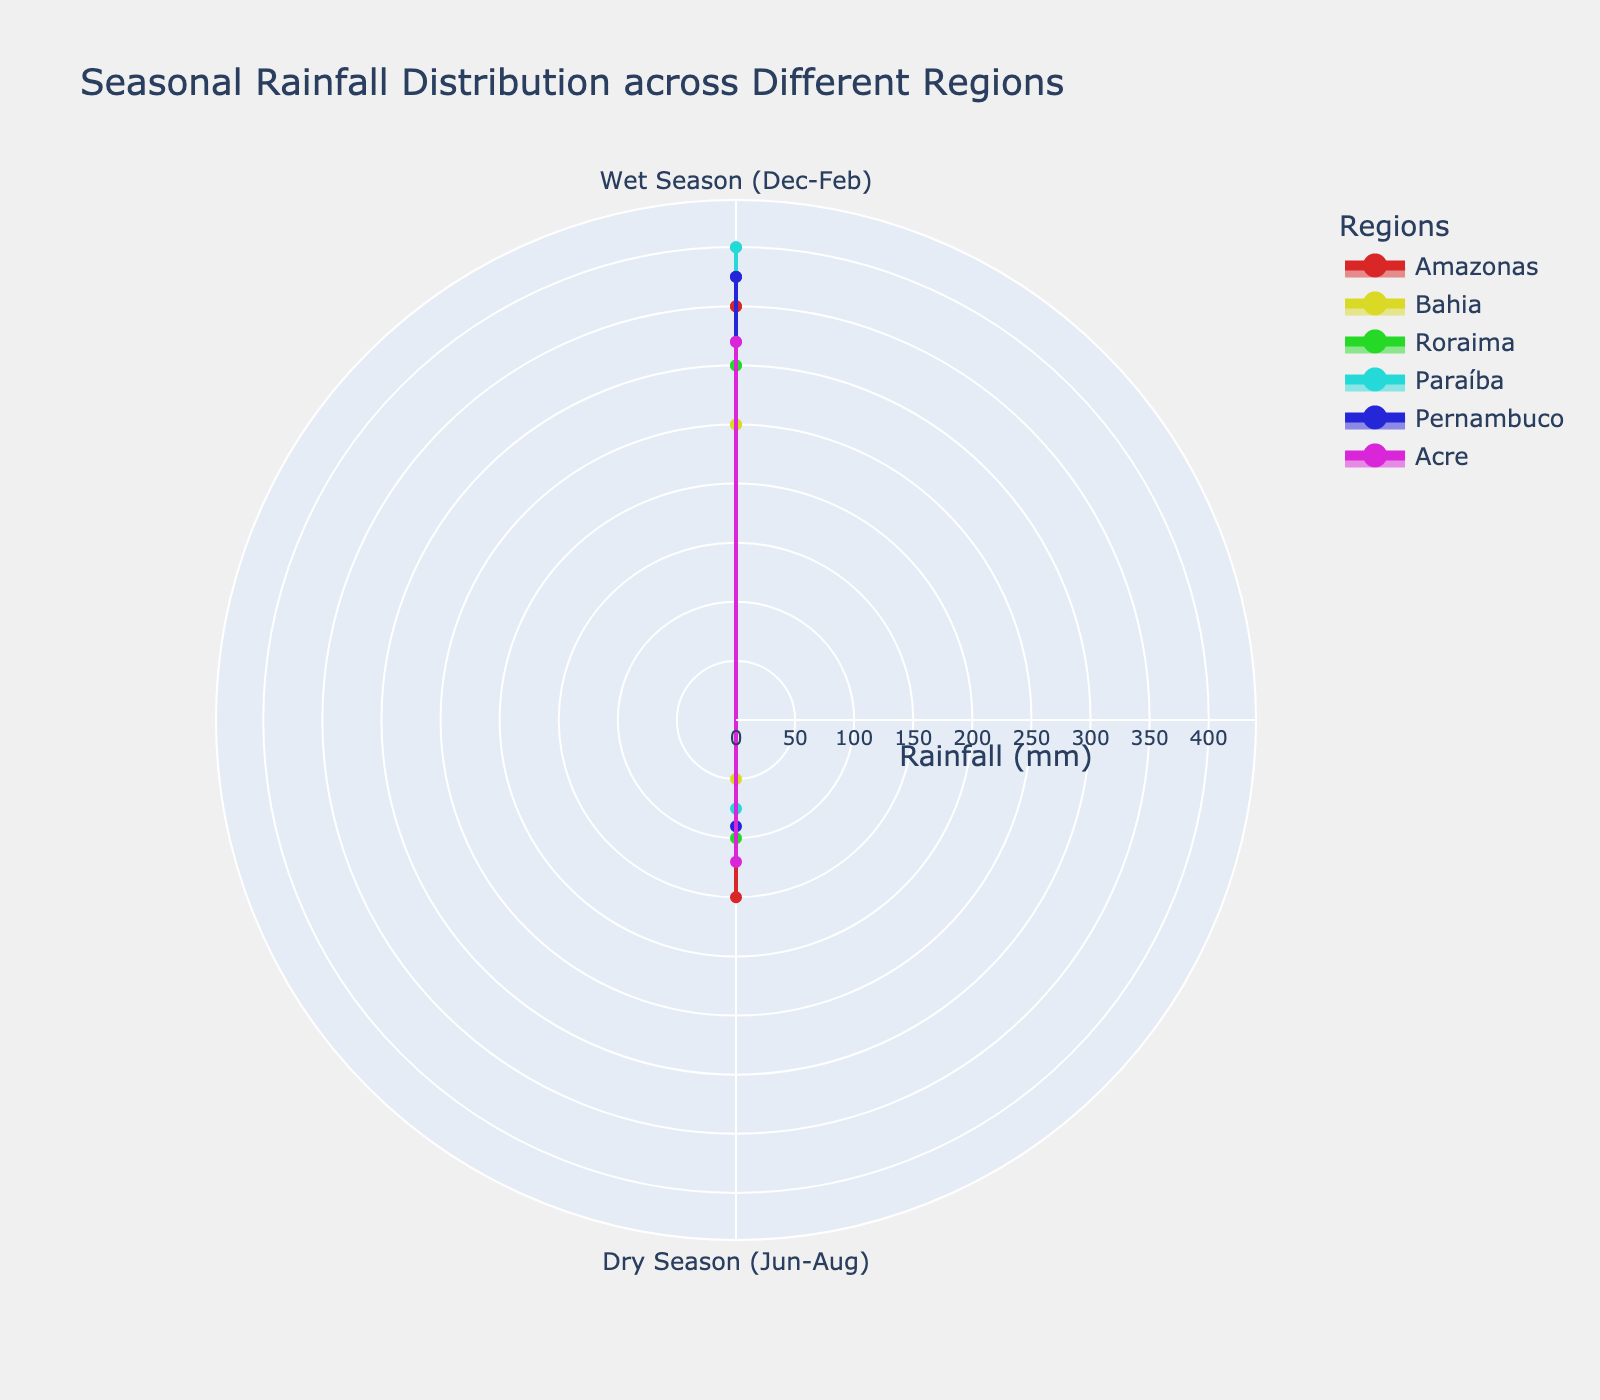What is the title of the chart? The title is usually located at the top of the chart and provides a summary of what the chart represents. In this case, it reads "Seasonal Rainfall Distribution across Different Regions."
Answer: Seasonal Rainfall Distribution across Different Regions How many regions are compared in this chart? Each region in the chart has a unique color and name. There are six distinct regions shown in the legend.
Answer: Six regions What is the rainfall range represented in the radial axis? The radial axis typically shows the range for the data. Here, it is labeled with a title "Rainfall (mm)" and has a visible range starting from 0 up to a bit beyond the maximum rainfall, which is 400 mm. The defined range is approximately 0 to 440 mm.
Answer: 0 to 440 mm Which region receives the highest rainfall during the wet season? By looking at the radial distance during the wet season segment, the region with the highest point will be the one with the greatest rainfall. In this case, Paráíba reaches the highest point at 400 mm.
Answer: Paráíba Compare rainfall between Amazonas and Bahia in the dry season. Which region receives more rainfall? Check the segments corresponding to the dry season for both regions. Amazonas has a rainfall of 150 mm, while Bahia has 50 mm. Therefore, Amazonas receives more rainfall.
Answer: Amazonas What is the total rainfall for Acre in both seasons? Combine the rainfall values for both seasons listed for Acre (320 mm in the wet season and 120 mm in the dry season), resulting in a total of 320 + 120 = 440 mm.
Answer: 440 mm Which region shows the smallest difference in rainfall between wet and dry seasons? Calculate the difference in rainfall between the wet and dry seasons for each region and identify the smallest difference. The differences are:
Amazonas: 350 - 150 = 200 mm
Bahia: 250 - 50 = 200 mm
Roraima: 300 - 100 = 200 mm
Paráíba: 400 - 75 = 325 mm
Pernambuco: 375 - 90 = 285 mm
Acre: 320 - 120 = 200 mm
Hence, Amazonas, Bahia, Roraima, and Acre all show the smallest difference of 200 mm.
Answer: Amazonas, Bahia, Roraima, Acre Which region has the most varied rainfall across both seasons? Examine each region's maximum and minimum rainfall values. Calculate the variance for each:
Amazonas: 350 - 150 = 200 mm
Bahia: 250 - 50 = 200 mm
Roraima: 300 - 100 = 200 mm
Paráíba: 400 - 75 = 325 mm
Pernambuco: 375 - 90 = 285 mm
Acre: 320 - 120 = 200 mm
Paráíba has the most varied rainfall with a range of 325 mm.
Answer: Paráíba What shape do the areas plotted on this Polar Area Chart resemble? The areas are filled regions enclosed by line segments connecting points. Each region forms a closed polygon, where the shape is dictated by the number of seasons and the respective rainfall values. The specific shape can look irregular depending on the specifics of the rainfall distribution.
Answer: Irregular polygons 